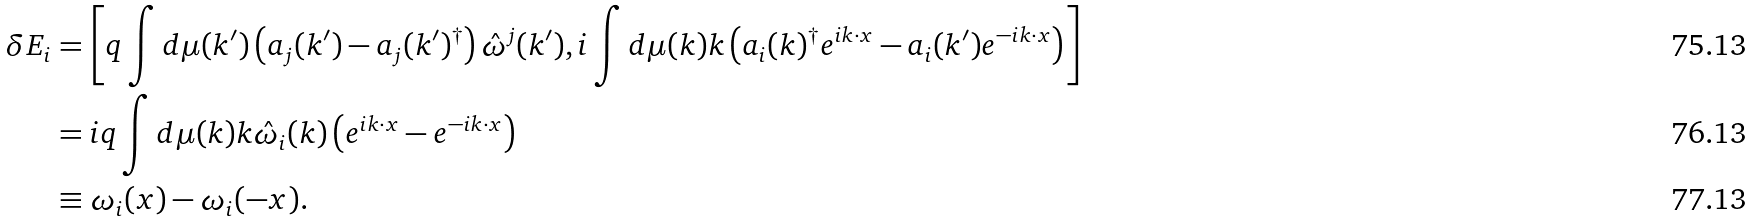<formula> <loc_0><loc_0><loc_500><loc_500>\delta E _ { i } & = \left [ q \int d \mu ( { k } ^ { \prime } ) \left ( a _ { j } ( { k } ^ { \prime } ) - a _ { j } ( { k } ^ { \prime } ) ^ { \dagger } \right ) \hat { \omega } ^ { j } ( k ^ { \prime } ) , i \int d \mu ( { k } ) k \left ( a _ { i } ( { k } ) ^ { \dagger } e ^ { i k \cdot x } - a _ { i } ( { k } ^ { \prime } ) e ^ { - i k \cdot x } \right ) \right ] \\ & = i q \int d \mu ( { k } ) k \hat { \omega } _ { i } ( k ) \left ( e ^ { i k \cdot x } - e ^ { - i k \cdot x } \right ) \\ & \equiv \omega _ { i } ( x ) - \omega _ { i } ( - x ) .</formula> 